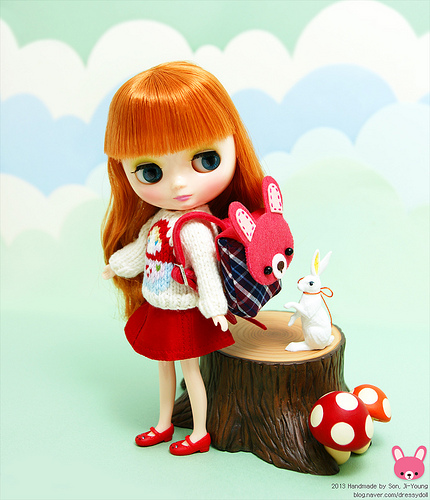<image>
Is the mushroom under the tree trunk? Yes. The mushroom is positioned underneath the tree trunk, with the tree trunk above it in the vertical space. 